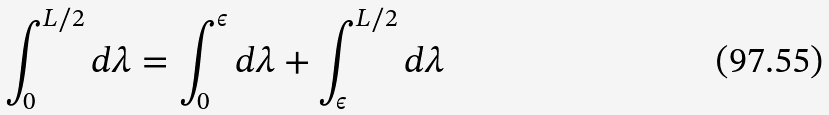Convert formula to latex. <formula><loc_0><loc_0><loc_500><loc_500>\int _ { 0 } ^ { L / 2 } d \lambda = \int _ { 0 } ^ { \epsilon } d \lambda + \int _ { \epsilon } ^ { L / 2 } d \lambda</formula> 